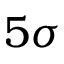<formula> <loc_0><loc_0><loc_500><loc_500>5 \sigma</formula> 